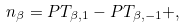Convert formula to latex. <formula><loc_0><loc_0><loc_500><loc_500>n _ { \beta } = P T _ { \beta , 1 } - P T _ { \beta , - 1 } + ,</formula> 